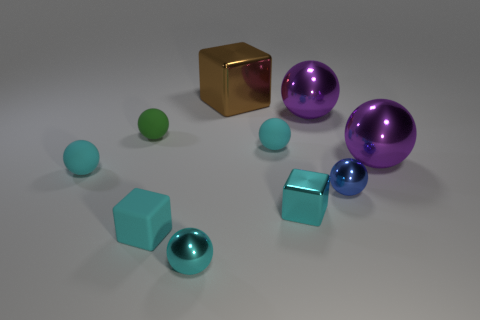Subtract all tiny balls. How many balls are left? 2 Subtract all balls. How many objects are left? 3 Subtract all cyan cylinders. How many cyan balls are left? 3 Subtract 2 blocks. How many blocks are left? 1 Add 5 rubber cubes. How many rubber cubes exist? 6 Subtract all cyan spheres. How many spheres are left? 4 Subtract 0 green cylinders. How many objects are left? 10 Subtract all yellow cubes. Subtract all purple balls. How many cubes are left? 3 Subtract all small blocks. Subtract all big brown cubes. How many objects are left? 7 Add 8 small cyan rubber balls. How many small cyan rubber balls are left? 10 